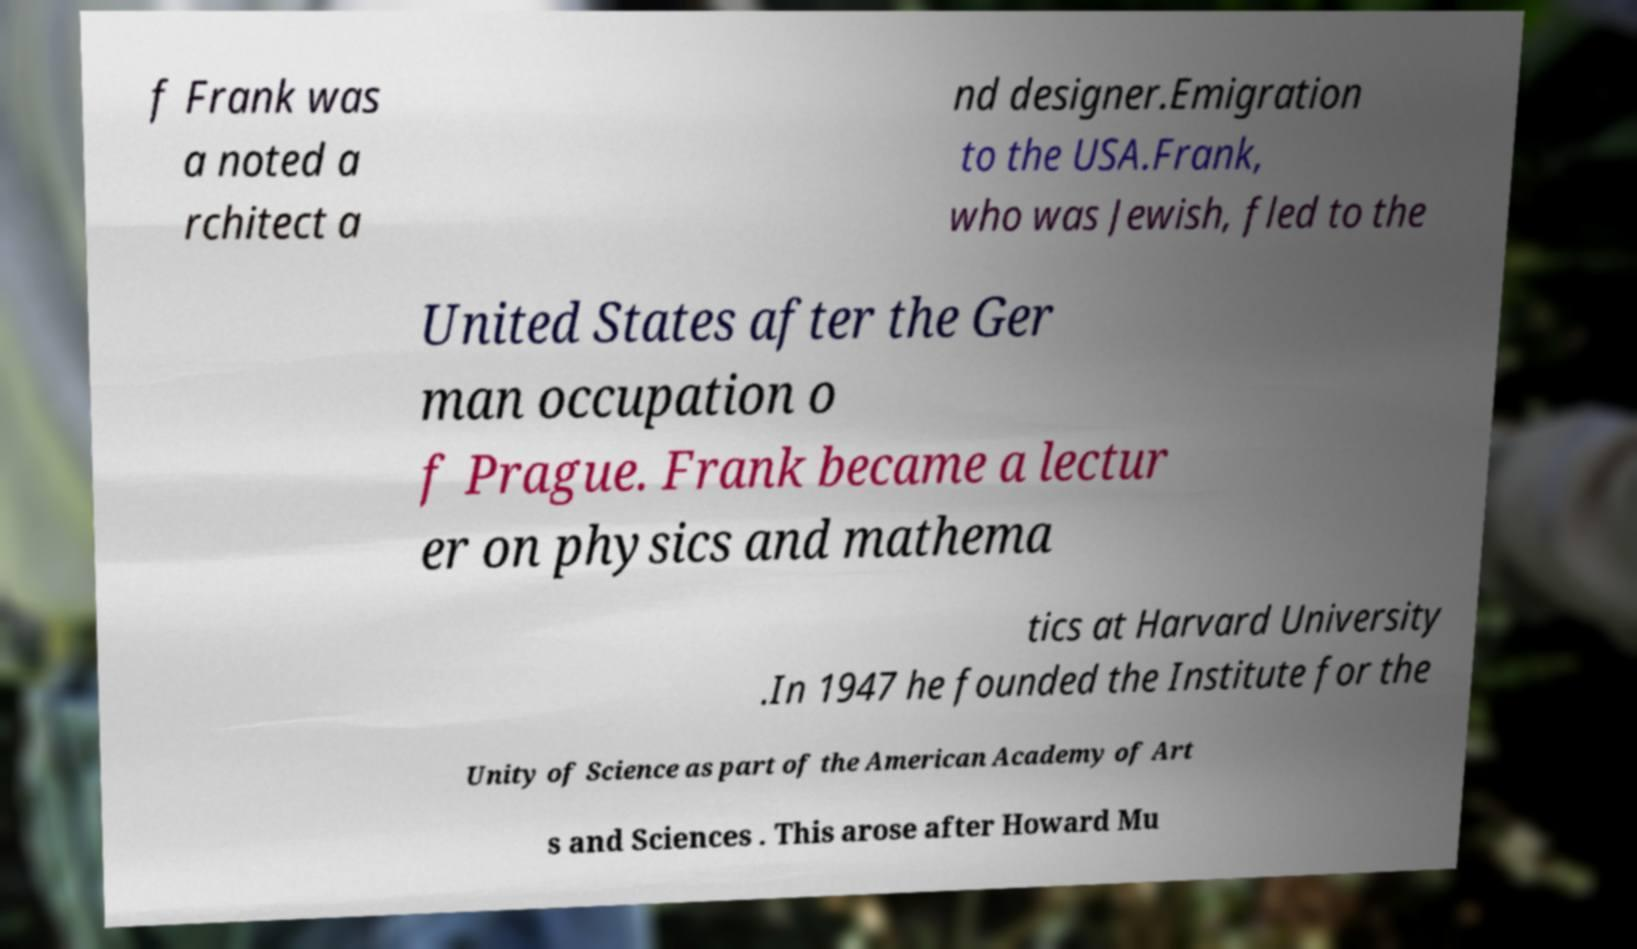Can you accurately transcribe the text from the provided image for me? f Frank was a noted a rchitect a nd designer.Emigration to the USA.Frank, who was Jewish, fled to the United States after the Ger man occupation o f Prague. Frank became a lectur er on physics and mathema tics at Harvard University .In 1947 he founded the Institute for the Unity of Science as part of the American Academy of Art s and Sciences . This arose after Howard Mu 